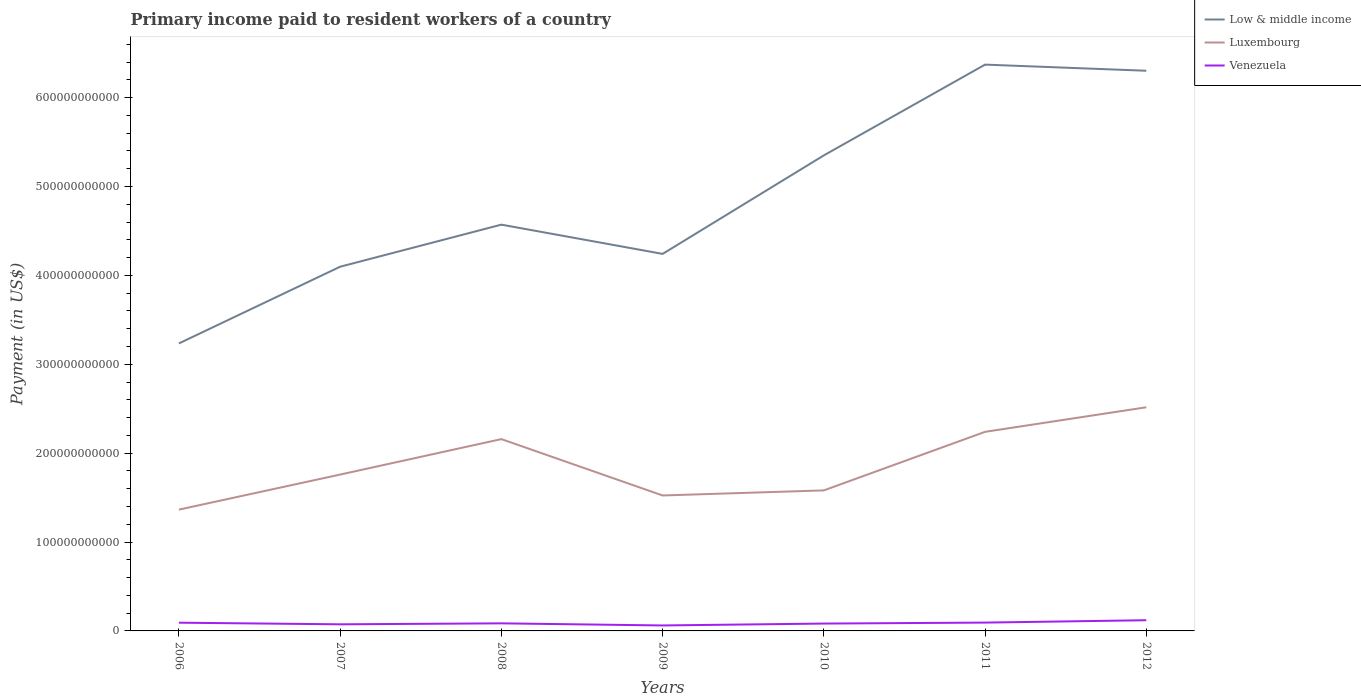Does the line corresponding to Venezuela intersect with the line corresponding to Luxembourg?
Keep it short and to the point. No. Across all years, what is the maximum amount paid to workers in Luxembourg?
Provide a short and direct response. 1.36e+11. In which year was the amount paid to workers in Low & middle income maximum?
Your answer should be compact. 2006. What is the total amount paid to workers in Low & middle income in the graph?
Your response must be concise. -8.63e+1. What is the difference between the highest and the second highest amount paid to workers in Low & middle income?
Your answer should be very brief. 3.14e+11. What is the difference between the highest and the lowest amount paid to workers in Luxembourg?
Provide a short and direct response. 3. Is the amount paid to workers in Venezuela strictly greater than the amount paid to workers in Luxembourg over the years?
Give a very brief answer. Yes. How many lines are there?
Offer a terse response. 3. How many years are there in the graph?
Make the answer very short. 7. What is the difference between two consecutive major ticks on the Y-axis?
Ensure brevity in your answer.  1.00e+11. Does the graph contain any zero values?
Provide a succinct answer. No. How many legend labels are there?
Make the answer very short. 3. How are the legend labels stacked?
Provide a succinct answer. Vertical. What is the title of the graph?
Your answer should be very brief. Primary income paid to resident workers of a country. What is the label or title of the Y-axis?
Keep it short and to the point. Payment (in US$). What is the Payment (in US$) in Low & middle income in 2006?
Your response must be concise. 3.23e+11. What is the Payment (in US$) of Luxembourg in 2006?
Your answer should be very brief. 1.36e+11. What is the Payment (in US$) in Venezuela in 2006?
Your response must be concise. 9.27e+09. What is the Payment (in US$) of Low & middle income in 2007?
Make the answer very short. 4.10e+11. What is the Payment (in US$) in Luxembourg in 2007?
Make the answer very short. 1.76e+11. What is the Payment (in US$) of Venezuela in 2007?
Provide a short and direct response. 7.44e+09. What is the Payment (in US$) of Low & middle income in 2008?
Your answer should be very brief. 4.57e+11. What is the Payment (in US$) of Luxembourg in 2008?
Ensure brevity in your answer.  2.16e+11. What is the Payment (in US$) of Venezuela in 2008?
Give a very brief answer. 8.53e+09. What is the Payment (in US$) in Low & middle income in 2009?
Provide a succinct answer. 4.24e+11. What is the Payment (in US$) of Luxembourg in 2009?
Provide a succinct answer. 1.52e+11. What is the Payment (in US$) of Venezuela in 2009?
Your answer should be compact. 6.15e+09. What is the Payment (in US$) in Low & middle income in 2010?
Offer a terse response. 5.35e+11. What is the Payment (in US$) in Luxembourg in 2010?
Give a very brief answer. 1.58e+11. What is the Payment (in US$) in Venezuela in 2010?
Offer a very short reply. 8.28e+09. What is the Payment (in US$) in Low & middle income in 2011?
Offer a very short reply. 6.37e+11. What is the Payment (in US$) in Luxembourg in 2011?
Provide a short and direct response. 2.24e+11. What is the Payment (in US$) in Venezuela in 2011?
Keep it short and to the point. 9.36e+09. What is the Payment (in US$) in Low & middle income in 2012?
Keep it short and to the point. 6.30e+11. What is the Payment (in US$) of Luxembourg in 2012?
Your answer should be very brief. 2.52e+11. What is the Payment (in US$) in Venezuela in 2012?
Offer a very short reply. 1.20e+1. Across all years, what is the maximum Payment (in US$) in Low & middle income?
Offer a terse response. 6.37e+11. Across all years, what is the maximum Payment (in US$) of Luxembourg?
Ensure brevity in your answer.  2.52e+11. Across all years, what is the maximum Payment (in US$) of Venezuela?
Your response must be concise. 1.20e+1. Across all years, what is the minimum Payment (in US$) of Low & middle income?
Give a very brief answer. 3.23e+11. Across all years, what is the minimum Payment (in US$) of Luxembourg?
Your answer should be compact. 1.36e+11. Across all years, what is the minimum Payment (in US$) in Venezuela?
Offer a terse response. 6.15e+09. What is the total Payment (in US$) in Low & middle income in the graph?
Offer a very short reply. 3.42e+12. What is the total Payment (in US$) of Luxembourg in the graph?
Ensure brevity in your answer.  1.31e+12. What is the total Payment (in US$) of Venezuela in the graph?
Keep it short and to the point. 6.11e+1. What is the difference between the Payment (in US$) of Low & middle income in 2006 and that in 2007?
Offer a very short reply. -8.63e+1. What is the difference between the Payment (in US$) of Luxembourg in 2006 and that in 2007?
Your answer should be very brief. -3.94e+1. What is the difference between the Payment (in US$) in Venezuela in 2006 and that in 2007?
Keep it short and to the point. 1.83e+09. What is the difference between the Payment (in US$) of Low & middle income in 2006 and that in 2008?
Provide a short and direct response. -1.34e+11. What is the difference between the Payment (in US$) of Luxembourg in 2006 and that in 2008?
Offer a very short reply. -7.93e+1. What is the difference between the Payment (in US$) in Venezuela in 2006 and that in 2008?
Keep it short and to the point. 7.44e+08. What is the difference between the Payment (in US$) of Low & middle income in 2006 and that in 2009?
Give a very brief answer. -1.01e+11. What is the difference between the Payment (in US$) of Luxembourg in 2006 and that in 2009?
Offer a terse response. -1.59e+1. What is the difference between the Payment (in US$) in Venezuela in 2006 and that in 2009?
Your answer should be compact. 3.12e+09. What is the difference between the Payment (in US$) of Low & middle income in 2006 and that in 2010?
Provide a short and direct response. -2.12e+11. What is the difference between the Payment (in US$) in Luxembourg in 2006 and that in 2010?
Give a very brief answer. -2.16e+1. What is the difference between the Payment (in US$) of Venezuela in 2006 and that in 2010?
Ensure brevity in your answer.  9.86e+08. What is the difference between the Payment (in US$) in Low & middle income in 2006 and that in 2011?
Your response must be concise. -3.14e+11. What is the difference between the Payment (in US$) in Luxembourg in 2006 and that in 2011?
Ensure brevity in your answer.  -8.75e+1. What is the difference between the Payment (in US$) of Venezuela in 2006 and that in 2011?
Make the answer very short. -9.10e+07. What is the difference between the Payment (in US$) in Low & middle income in 2006 and that in 2012?
Offer a very short reply. -3.07e+11. What is the difference between the Payment (in US$) of Luxembourg in 2006 and that in 2012?
Offer a very short reply. -1.15e+11. What is the difference between the Payment (in US$) in Venezuela in 2006 and that in 2012?
Your answer should be very brief. -2.78e+09. What is the difference between the Payment (in US$) of Low & middle income in 2007 and that in 2008?
Offer a terse response. -4.73e+1. What is the difference between the Payment (in US$) of Luxembourg in 2007 and that in 2008?
Keep it short and to the point. -3.99e+1. What is the difference between the Payment (in US$) in Venezuela in 2007 and that in 2008?
Ensure brevity in your answer.  -1.09e+09. What is the difference between the Payment (in US$) in Low & middle income in 2007 and that in 2009?
Your response must be concise. -1.44e+1. What is the difference between the Payment (in US$) in Luxembourg in 2007 and that in 2009?
Give a very brief answer. 2.35e+1. What is the difference between the Payment (in US$) in Venezuela in 2007 and that in 2009?
Give a very brief answer. 1.29e+09. What is the difference between the Payment (in US$) of Low & middle income in 2007 and that in 2010?
Your answer should be very brief. -1.25e+11. What is the difference between the Payment (in US$) of Luxembourg in 2007 and that in 2010?
Give a very brief answer. 1.78e+1. What is the difference between the Payment (in US$) in Venezuela in 2007 and that in 2010?
Ensure brevity in your answer.  -8.44e+08. What is the difference between the Payment (in US$) of Low & middle income in 2007 and that in 2011?
Your answer should be compact. -2.27e+11. What is the difference between the Payment (in US$) of Luxembourg in 2007 and that in 2011?
Provide a succinct answer. -4.81e+1. What is the difference between the Payment (in US$) in Venezuela in 2007 and that in 2011?
Keep it short and to the point. -1.92e+09. What is the difference between the Payment (in US$) of Low & middle income in 2007 and that in 2012?
Make the answer very short. -2.20e+11. What is the difference between the Payment (in US$) of Luxembourg in 2007 and that in 2012?
Keep it short and to the point. -7.57e+1. What is the difference between the Payment (in US$) in Venezuela in 2007 and that in 2012?
Provide a short and direct response. -4.60e+09. What is the difference between the Payment (in US$) of Low & middle income in 2008 and that in 2009?
Keep it short and to the point. 3.29e+1. What is the difference between the Payment (in US$) of Luxembourg in 2008 and that in 2009?
Provide a short and direct response. 6.34e+1. What is the difference between the Payment (in US$) of Venezuela in 2008 and that in 2009?
Provide a succinct answer. 2.38e+09. What is the difference between the Payment (in US$) in Low & middle income in 2008 and that in 2010?
Your answer should be compact. -7.79e+1. What is the difference between the Payment (in US$) in Luxembourg in 2008 and that in 2010?
Offer a terse response. 5.77e+1. What is the difference between the Payment (in US$) of Venezuela in 2008 and that in 2010?
Keep it short and to the point. 2.42e+08. What is the difference between the Payment (in US$) in Low & middle income in 2008 and that in 2011?
Give a very brief answer. -1.80e+11. What is the difference between the Payment (in US$) in Luxembourg in 2008 and that in 2011?
Provide a short and direct response. -8.18e+09. What is the difference between the Payment (in US$) in Venezuela in 2008 and that in 2011?
Give a very brief answer. -8.35e+08. What is the difference between the Payment (in US$) in Low & middle income in 2008 and that in 2012?
Provide a succinct answer. -1.73e+11. What is the difference between the Payment (in US$) of Luxembourg in 2008 and that in 2012?
Your answer should be compact. -3.58e+1. What is the difference between the Payment (in US$) in Venezuela in 2008 and that in 2012?
Keep it short and to the point. -3.52e+09. What is the difference between the Payment (in US$) in Low & middle income in 2009 and that in 2010?
Make the answer very short. -1.11e+11. What is the difference between the Payment (in US$) in Luxembourg in 2009 and that in 2010?
Your answer should be very brief. -5.72e+09. What is the difference between the Payment (in US$) of Venezuela in 2009 and that in 2010?
Offer a terse response. -2.14e+09. What is the difference between the Payment (in US$) in Low & middle income in 2009 and that in 2011?
Give a very brief answer. -2.13e+11. What is the difference between the Payment (in US$) in Luxembourg in 2009 and that in 2011?
Your answer should be very brief. -7.16e+1. What is the difference between the Payment (in US$) of Venezuela in 2009 and that in 2011?
Provide a succinct answer. -3.21e+09. What is the difference between the Payment (in US$) of Low & middle income in 2009 and that in 2012?
Your answer should be very brief. -2.06e+11. What is the difference between the Payment (in US$) in Luxembourg in 2009 and that in 2012?
Your answer should be compact. -9.92e+1. What is the difference between the Payment (in US$) in Venezuela in 2009 and that in 2012?
Provide a short and direct response. -5.90e+09. What is the difference between the Payment (in US$) in Low & middle income in 2010 and that in 2011?
Make the answer very short. -1.02e+11. What is the difference between the Payment (in US$) of Luxembourg in 2010 and that in 2011?
Give a very brief answer. -6.59e+1. What is the difference between the Payment (in US$) in Venezuela in 2010 and that in 2011?
Your response must be concise. -1.08e+09. What is the difference between the Payment (in US$) of Low & middle income in 2010 and that in 2012?
Provide a short and direct response. -9.52e+1. What is the difference between the Payment (in US$) of Luxembourg in 2010 and that in 2012?
Your answer should be compact. -9.35e+1. What is the difference between the Payment (in US$) in Venezuela in 2010 and that in 2012?
Give a very brief answer. -3.76e+09. What is the difference between the Payment (in US$) of Low & middle income in 2011 and that in 2012?
Your answer should be very brief. 6.90e+09. What is the difference between the Payment (in US$) in Luxembourg in 2011 and that in 2012?
Give a very brief answer. -2.76e+1. What is the difference between the Payment (in US$) in Venezuela in 2011 and that in 2012?
Make the answer very short. -2.68e+09. What is the difference between the Payment (in US$) of Low & middle income in 2006 and the Payment (in US$) of Luxembourg in 2007?
Give a very brief answer. 1.48e+11. What is the difference between the Payment (in US$) of Low & middle income in 2006 and the Payment (in US$) of Venezuela in 2007?
Your response must be concise. 3.16e+11. What is the difference between the Payment (in US$) in Luxembourg in 2006 and the Payment (in US$) in Venezuela in 2007?
Make the answer very short. 1.29e+11. What is the difference between the Payment (in US$) of Low & middle income in 2006 and the Payment (in US$) of Luxembourg in 2008?
Your answer should be compact. 1.08e+11. What is the difference between the Payment (in US$) of Low & middle income in 2006 and the Payment (in US$) of Venezuela in 2008?
Keep it short and to the point. 3.15e+11. What is the difference between the Payment (in US$) in Luxembourg in 2006 and the Payment (in US$) in Venezuela in 2008?
Give a very brief answer. 1.28e+11. What is the difference between the Payment (in US$) of Low & middle income in 2006 and the Payment (in US$) of Luxembourg in 2009?
Provide a succinct answer. 1.71e+11. What is the difference between the Payment (in US$) in Low & middle income in 2006 and the Payment (in US$) in Venezuela in 2009?
Your answer should be compact. 3.17e+11. What is the difference between the Payment (in US$) in Luxembourg in 2006 and the Payment (in US$) in Venezuela in 2009?
Give a very brief answer. 1.30e+11. What is the difference between the Payment (in US$) in Low & middle income in 2006 and the Payment (in US$) in Luxembourg in 2010?
Provide a succinct answer. 1.65e+11. What is the difference between the Payment (in US$) in Low & middle income in 2006 and the Payment (in US$) in Venezuela in 2010?
Your answer should be compact. 3.15e+11. What is the difference between the Payment (in US$) in Luxembourg in 2006 and the Payment (in US$) in Venezuela in 2010?
Provide a short and direct response. 1.28e+11. What is the difference between the Payment (in US$) of Low & middle income in 2006 and the Payment (in US$) of Luxembourg in 2011?
Ensure brevity in your answer.  9.95e+1. What is the difference between the Payment (in US$) of Low & middle income in 2006 and the Payment (in US$) of Venezuela in 2011?
Ensure brevity in your answer.  3.14e+11. What is the difference between the Payment (in US$) in Luxembourg in 2006 and the Payment (in US$) in Venezuela in 2011?
Make the answer very short. 1.27e+11. What is the difference between the Payment (in US$) of Low & middle income in 2006 and the Payment (in US$) of Luxembourg in 2012?
Offer a very short reply. 7.18e+1. What is the difference between the Payment (in US$) of Low & middle income in 2006 and the Payment (in US$) of Venezuela in 2012?
Ensure brevity in your answer.  3.11e+11. What is the difference between the Payment (in US$) of Luxembourg in 2006 and the Payment (in US$) of Venezuela in 2012?
Provide a short and direct response. 1.24e+11. What is the difference between the Payment (in US$) in Low & middle income in 2007 and the Payment (in US$) in Luxembourg in 2008?
Your answer should be compact. 1.94e+11. What is the difference between the Payment (in US$) in Low & middle income in 2007 and the Payment (in US$) in Venezuela in 2008?
Your response must be concise. 4.01e+11. What is the difference between the Payment (in US$) in Luxembourg in 2007 and the Payment (in US$) in Venezuela in 2008?
Provide a succinct answer. 1.67e+11. What is the difference between the Payment (in US$) in Low & middle income in 2007 and the Payment (in US$) in Luxembourg in 2009?
Provide a succinct answer. 2.57e+11. What is the difference between the Payment (in US$) of Low & middle income in 2007 and the Payment (in US$) of Venezuela in 2009?
Provide a short and direct response. 4.04e+11. What is the difference between the Payment (in US$) in Luxembourg in 2007 and the Payment (in US$) in Venezuela in 2009?
Your response must be concise. 1.70e+11. What is the difference between the Payment (in US$) of Low & middle income in 2007 and the Payment (in US$) of Luxembourg in 2010?
Provide a short and direct response. 2.52e+11. What is the difference between the Payment (in US$) in Low & middle income in 2007 and the Payment (in US$) in Venezuela in 2010?
Offer a terse response. 4.01e+11. What is the difference between the Payment (in US$) of Luxembourg in 2007 and the Payment (in US$) of Venezuela in 2010?
Provide a succinct answer. 1.68e+11. What is the difference between the Payment (in US$) in Low & middle income in 2007 and the Payment (in US$) in Luxembourg in 2011?
Your answer should be compact. 1.86e+11. What is the difference between the Payment (in US$) in Low & middle income in 2007 and the Payment (in US$) in Venezuela in 2011?
Provide a succinct answer. 4.00e+11. What is the difference between the Payment (in US$) in Luxembourg in 2007 and the Payment (in US$) in Venezuela in 2011?
Provide a short and direct response. 1.67e+11. What is the difference between the Payment (in US$) in Low & middle income in 2007 and the Payment (in US$) in Luxembourg in 2012?
Make the answer very short. 1.58e+11. What is the difference between the Payment (in US$) in Low & middle income in 2007 and the Payment (in US$) in Venezuela in 2012?
Make the answer very short. 3.98e+11. What is the difference between the Payment (in US$) in Luxembourg in 2007 and the Payment (in US$) in Venezuela in 2012?
Offer a very short reply. 1.64e+11. What is the difference between the Payment (in US$) of Low & middle income in 2008 and the Payment (in US$) of Luxembourg in 2009?
Provide a succinct answer. 3.05e+11. What is the difference between the Payment (in US$) in Low & middle income in 2008 and the Payment (in US$) in Venezuela in 2009?
Provide a short and direct response. 4.51e+11. What is the difference between the Payment (in US$) in Luxembourg in 2008 and the Payment (in US$) in Venezuela in 2009?
Your response must be concise. 2.10e+11. What is the difference between the Payment (in US$) of Low & middle income in 2008 and the Payment (in US$) of Luxembourg in 2010?
Offer a terse response. 2.99e+11. What is the difference between the Payment (in US$) of Low & middle income in 2008 and the Payment (in US$) of Venezuela in 2010?
Keep it short and to the point. 4.49e+11. What is the difference between the Payment (in US$) of Luxembourg in 2008 and the Payment (in US$) of Venezuela in 2010?
Offer a terse response. 2.08e+11. What is the difference between the Payment (in US$) of Low & middle income in 2008 and the Payment (in US$) of Luxembourg in 2011?
Ensure brevity in your answer.  2.33e+11. What is the difference between the Payment (in US$) of Low & middle income in 2008 and the Payment (in US$) of Venezuela in 2011?
Your answer should be very brief. 4.48e+11. What is the difference between the Payment (in US$) in Luxembourg in 2008 and the Payment (in US$) in Venezuela in 2011?
Provide a short and direct response. 2.06e+11. What is the difference between the Payment (in US$) of Low & middle income in 2008 and the Payment (in US$) of Luxembourg in 2012?
Offer a terse response. 2.05e+11. What is the difference between the Payment (in US$) in Low & middle income in 2008 and the Payment (in US$) in Venezuela in 2012?
Your answer should be compact. 4.45e+11. What is the difference between the Payment (in US$) of Luxembourg in 2008 and the Payment (in US$) of Venezuela in 2012?
Offer a very short reply. 2.04e+11. What is the difference between the Payment (in US$) in Low & middle income in 2009 and the Payment (in US$) in Luxembourg in 2010?
Make the answer very short. 2.66e+11. What is the difference between the Payment (in US$) in Low & middle income in 2009 and the Payment (in US$) in Venezuela in 2010?
Your answer should be compact. 4.16e+11. What is the difference between the Payment (in US$) in Luxembourg in 2009 and the Payment (in US$) in Venezuela in 2010?
Provide a succinct answer. 1.44e+11. What is the difference between the Payment (in US$) of Low & middle income in 2009 and the Payment (in US$) of Luxembourg in 2011?
Offer a terse response. 2.00e+11. What is the difference between the Payment (in US$) in Low & middle income in 2009 and the Payment (in US$) in Venezuela in 2011?
Keep it short and to the point. 4.15e+11. What is the difference between the Payment (in US$) of Luxembourg in 2009 and the Payment (in US$) of Venezuela in 2011?
Give a very brief answer. 1.43e+11. What is the difference between the Payment (in US$) of Low & middle income in 2009 and the Payment (in US$) of Luxembourg in 2012?
Give a very brief answer. 1.73e+11. What is the difference between the Payment (in US$) of Low & middle income in 2009 and the Payment (in US$) of Venezuela in 2012?
Your response must be concise. 4.12e+11. What is the difference between the Payment (in US$) of Luxembourg in 2009 and the Payment (in US$) of Venezuela in 2012?
Your response must be concise. 1.40e+11. What is the difference between the Payment (in US$) of Low & middle income in 2010 and the Payment (in US$) of Luxembourg in 2011?
Keep it short and to the point. 3.11e+11. What is the difference between the Payment (in US$) in Low & middle income in 2010 and the Payment (in US$) in Venezuela in 2011?
Make the answer very short. 5.26e+11. What is the difference between the Payment (in US$) in Luxembourg in 2010 and the Payment (in US$) in Venezuela in 2011?
Give a very brief answer. 1.49e+11. What is the difference between the Payment (in US$) of Low & middle income in 2010 and the Payment (in US$) of Luxembourg in 2012?
Keep it short and to the point. 2.83e+11. What is the difference between the Payment (in US$) of Low & middle income in 2010 and the Payment (in US$) of Venezuela in 2012?
Make the answer very short. 5.23e+11. What is the difference between the Payment (in US$) of Luxembourg in 2010 and the Payment (in US$) of Venezuela in 2012?
Offer a terse response. 1.46e+11. What is the difference between the Payment (in US$) of Low & middle income in 2011 and the Payment (in US$) of Luxembourg in 2012?
Offer a terse response. 3.86e+11. What is the difference between the Payment (in US$) in Low & middle income in 2011 and the Payment (in US$) in Venezuela in 2012?
Make the answer very short. 6.25e+11. What is the difference between the Payment (in US$) in Luxembourg in 2011 and the Payment (in US$) in Venezuela in 2012?
Keep it short and to the point. 2.12e+11. What is the average Payment (in US$) in Low & middle income per year?
Offer a very short reply. 4.88e+11. What is the average Payment (in US$) in Luxembourg per year?
Your answer should be very brief. 1.88e+11. What is the average Payment (in US$) in Venezuela per year?
Ensure brevity in your answer.  8.73e+09. In the year 2006, what is the difference between the Payment (in US$) in Low & middle income and Payment (in US$) in Luxembourg?
Offer a terse response. 1.87e+11. In the year 2006, what is the difference between the Payment (in US$) in Low & middle income and Payment (in US$) in Venezuela?
Your answer should be compact. 3.14e+11. In the year 2006, what is the difference between the Payment (in US$) of Luxembourg and Payment (in US$) of Venezuela?
Offer a terse response. 1.27e+11. In the year 2007, what is the difference between the Payment (in US$) in Low & middle income and Payment (in US$) in Luxembourg?
Give a very brief answer. 2.34e+11. In the year 2007, what is the difference between the Payment (in US$) of Low & middle income and Payment (in US$) of Venezuela?
Ensure brevity in your answer.  4.02e+11. In the year 2007, what is the difference between the Payment (in US$) of Luxembourg and Payment (in US$) of Venezuela?
Your response must be concise. 1.68e+11. In the year 2008, what is the difference between the Payment (in US$) of Low & middle income and Payment (in US$) of Luxembourg?
Keep it short and to the point. 2.41e+11. In the year 2008, what is the difference between the Payment (in US$) in Low & middle income and Payment (in US$) in Venezuela?
Keep it short and to the point. 4.49e+11. In the year 2008, what is the difference between the Payment (in US$) of Luxembourg and Payment (in US$) of Venezuela?
Your response must be concise. 2.07e+11. In the year 2009, what is the difference between the Payment (in US$) of Low & middle income and Payment (in US$) of Luxembourg?
Provide a succinct answer. 2.72e+11. In the year 2009, what is the difference between the Payment (in US$) in Low & middle income and Payment (in US$) in Venezuela?
Ensure brevity in your answer.  4.18e+11. In the year 2009, what is the difference between the Payment (in US$) of Luxembourg and Payment (in US$) of Venezuela?
Provide a short and direct response. 1.46e+11. In the year 2010, what is the difference between the Payment (in US$) of Low & middle income and Payment (in US$) of Luxembourg?
Provide a succinct answer. 3.77e+11. In the year 2010, what is the difference between the Payment (in US$) in Low & middle income and Payment (in US$) in Venezuela?
Your response must be concise. 5.27e+11. In the year 2010, what is the difference between the Payment (in US$) in Luxembourg and Payment (in US$) in Venezuela?
Ensure brevity in your answer.  1.50e+11. In the year 2011, what is the difference between the Payment (in US$) in Low & middle income and Payment (in US$) in Luxembourg?
Give a very brief answer. 4.13e+11. In the year 2011, what is the difference between the Payment (in US$) in Low & middle income and Payment (in US$) in Venezuela?
Keep it short and to the point. 6.28e+11. In the year 2011, what is the difference between the Payment (in US$) in Luxembourg and Payment (in US$) in Venezuela?
Ensure brevity in your answer.  2.15e+11. In the year 2012, what is the difference between the Payment (in US$) of Low & middle income and Payment (in US$) of Luxembourg?
Give a very brief answer. 3.79e+11. In the year 2012, what is the difference between the Payment (in US$) of Low & middle income and Payment (in US$) of Venezuela?
Your answer should be compact. 6.18e+11. In the year 2012, what is the difference between the Payment (in US$) of Luxembourg and Payment (in US$) of Venezuela?
Make the answer very short. 2.40e+11. What is the ratio of the Payment (in US$) of Low & middle income in 2006 to that in 2007?
Keep it short and to the point. 0.79. What is the ratio of the Payment (in US$) in Luxembourg in 2006 to that in 2007?
Ensure brevity in your answer.  0.78. What is the ratio of the Payment (in US$) of Venezuela in 2006 to that in 2007?
Keep it short and to the point. 1.25. What is the ratio of the Payment (in US$) in Low & middle income in 2006 to that in 2008?
Provide a short and direct response. 0.71. What is the ratio of the Payment (in US$) in Luxembourg in 2006 to that in 2008?
Provide a short and direct response. 0.63. What is the ratio of the Payment (in US$) in Venezuela in 2006 to that in 2008?
Offer a very short reply. 1.09. What is the ratio of the Payment (in US$) of Low & middle income in 2006 to that in 2009?
Your answer should be very brief. 0.76. What is the ratio of the Payment (in US$) in Luxembourg in 2006 to that in 2009?
Keep it short and to the point. 0.9. What is the ratio of the Payment (in US$) in Venezuela in 2006 to that in 2009?
Your answer should be compact. 1.51. What is the ratio of the Payment (in US$) of Low & middle income in 2006 to that in 2010?
Offer a terse response. 0.6. What is the ratio of the Payment (in US$) in Luxembourg in 2006 to that in 2010?
Your answer should be very brief. 0.86. What is the ratio of the Payment (in US$) in Venezuela in 2006 to that in 2010?
Offer a terse response. 1.12. What is the ratio of the Payment (in US$) in Low & middle income in 2006 to that in 2011?
Ensure brevity in your answer.  0.51. What is the ratio of the Payment (in US$) in Luxembourg in 2006 to that in 2011?
Provide a short and direct response. 0.61. What is the ratio of the Payment (in US$) of Venezuela in 2006 to that in 2011?
Keep it short and to the point. 0.99. What is the ratio of the Payment (in US$) in Low & middle income in 2006 to that in 2012?
Offer a terse response. 0.51. What is the ratio of the Payment (in US$) in Luxembourg in 2006 to that in 2012?
Offer a terse response. 0.54. What is the ratio of the Payment (in US$) in Venezuela in 2006 to that in 2012?
Make the answer very short. 0.77. What is the ratio of the Payment (in US$) in Low & middle income in 2007 to that in 2008?
Give a very brief answer. 0.9. What is the ratio of the Payment (in US$) of Luxembourg in 2007 to that in 2008?
Ensure brevity in your answer.  0.82. What is the ratio of the Payment (in US$) in Venezuela in 2007 to that in 2008?
Keep it short and to the point. 0.87. What is the ratio of the Payment (in US$) in Low & middle income in 2007 to that in 2009?
Offer a terse response. 0.97. What is the ratio of the Payment (in US$) in Luxembourg in 2007 to that in 2009?
Ensure brevity in your answer.  1.15. What is the ratio of the Payment (in US$) in Venezuela in 2007 to that in 2009?
Your answer should be very brief. 1.21. What is the ratio of the Payment (in US$) in Low & middle income in 2007 to that in 2010?
Give a very brief answer. 0.77. What is the ratio of the Payment (in US$) of Luxembourg in 2007 to that in 2010?
Provide a succinct answer. 1.11. What is the ratio of the Payment (in US$) in Venezuela in 2007 to that in 2010?
Your answer should be very brief. 0.9. What is the ratio of the Payment (in US$) in Low & middle income in 2007 to that in 2011?
Provide a succinct answer. 0.64. What is the ratio of the Payment (in US$) of Luxembourg in 2007 to that in 2011?
Give a very brief answer. 0.79. What is the ratio of the Payment (in US$) in Venezuela in 2007 to that in 2011?
Your answer should be very brief. 0.79. What is the ratio of the Payment (in US$) of Low & middle income in 2007 to that in 2012?
Keep it short and to the point. 0.65. What is the ratio of the Payment (in US$) of Luxembourg in 2007 to that in 2012?
Your answer should be very brief. 0.7. What is the ratio of the Payment (in US$) in Venezuela in 2007 to that in 2012?
Your answer should be very brief. 0.62. What is the ratio of the Payment (in US$) in Low & middle income in 2008 to that in 2009?
Keep it short and to the point. 1.08. What is the ratio of the Payment (in US$) of Luxembourg in 2008 to that in 2009?
Your response must be concise. 1.42. What is the ratio of the Payment (in US$) of Venezuela in 2008 to that in 2009?
Your response must be concise. 1.39. What is the ratio of the Payment (in US$) of Low & middle income in 2008 to that in 2010?
Your response must be concise. 0.85. What is the ratio of the Payment (in US$) in Luxembourg in 2008 to that in 2010?
Offer a terse response. 1.36. What is the ratio of the Payment (in US$) of Venezuela in 2008 to that in 2010?
Provide a short and direct response. 1.03. What is the ratio of the Payment (in US$) in Low & middle income in 2008 to that in 2011?
Offer a very short reply. 0.72. What is the ratio of the Payment (in US$) of Luxembourg in 2008 to that in 2011?
Ensure brevity in your answer.  0.96. What is the ratio of the Payment (in US$) in Venezuela in 2008 to that in 2011?
Ensure brevity in your answer.  0.91. What is the ratio of the Payment (in US$) in Low & middle income in 2008 to that in 2012?
Your response must be concise. 0.73. What is the ratio of the Payment (in US$) of Luxembourg in 2008 to that in 2012?
Provide a succinct answer. 0.86. What is the ratio of the Payment (in US$) in Venezuela in 2008 to that in 2012?
Your answer should be compact. 0.71. What is the ratio of the Payment (in US$) in Low & middle income in 2009 to that in 2010?
Your answer should be very brief. 0.79. What is the ratio of the Payment (in US$) of Luxembourg in 2009 to that in 2010?
Your response must be concise. 0.96. What is the ratio of the Payment (in US$) of Venezuela in 2009 to that in 2010?
Your answer should be very brief. 0.74. What is the ratio of the Payment (in US$) of Low & middle income in 2009 to that in 2011?
Your answer should be very brief. 0.67. What is the ratio of the Payment (in US$) of Luxembourg in 2009 to that in 2011?
Provide a succinct answer. 0.68. What is the ratio of the Payment (in US$) of Venezuela in 2009 to that in 2011?
Offer a terse response. 0.66. What is the ratio of the Payment (in US$) in Low & middle income in 2009 to that in 2012?
Your response must be concise. 0.67. What is the ratio of the Payment (in US$) of Luxembourg in 2009 to that in 2012?
Keep it short and to the point. 0.61. What is the ratio of the Payment (in US$) in Venezuela in 2009 to that in 2012?
Keep it short and to the point. 0.51. What is the ratio of the Payment (in US$) of Low & middle income in 2010 to that in 2011?
Give a very brief answer. 0.84. What is the ratio of the Payment (in US$) in Luxembourg in 2010 to that in 2011?
Offer a very short reply. 0.71. What is the ratio of the Payment (in US$) in Venezuela in 2010 to that in 2011?
Make the answer very short. 0.89. What is the ratio of the Payment (in US$) of Low & middle income in 2010 to that in 2012?
Give a very brief answer. 0.85. What is the ratio of the Payment (in US$) of Luxembourg in 2010 to that in 2012?
Give a very brief answer. 0.63. What is the ratio of the Payment (in US$) of Venezuela in 2010 to that in 2012?
Offer a terse response. 0.69. What is the ratio of the Payment (in US$) in Low & middle income in 2011 to that in 2012?
Offer a terse response. 1.01. What is the ratio of the Payment (in US$) of Luxembourg in 2011 to that in 2012?
Provide a short and direct response. 0.89. What is the ratio of the Payment (in US$) of Venezuela in 2011 to that in 2012?
Give a very brief answer. 0.78. What is the difference between the highest and the second highest Payment (in US$) of Low & middle income?
Provide a succinct answer. 6.90e+09. What is the difference between the highest and the second highest Payment (in US$) of Luxembourg?
Your answer should be very brief. 2.76e+1. What is the difference between the highest and the second highest Payment (in US$) in Venezuela?
Offer a very short reply. 2.68e+09. What is the difference between the highest and the lowest Payment (in US$) in Low & middle income?
Offer a very short reply. 3.14e+11. What is the difference between the highest and the lowest Payment (in US$) of Luxembourg?
Your answer should be compact. 1.15e+11. What is the difference between the highest and the lowest Payment (in US$) of Venezuela?
Offer a terse response. 5.90e+09. 